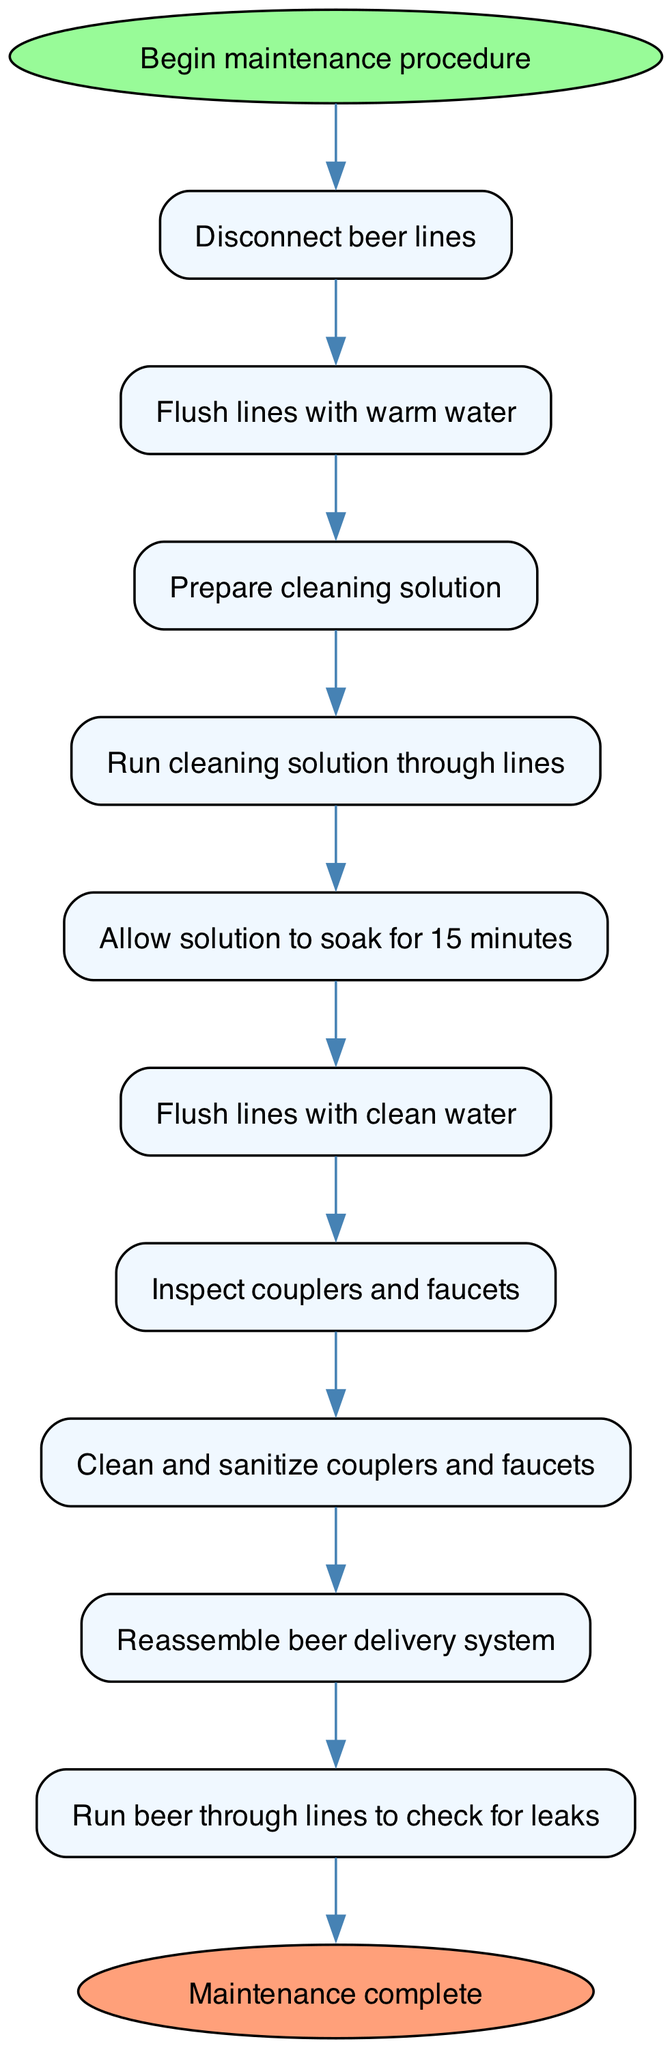What is the first step in the maintenance procedure? The first step is represented by the first node after the start point. It states "Disconnect beer lines," which indicates what action should begin the maintenance procedure.
Answer: Disconnect beer lines How many total steps are there in the diagram? The diagram includes ten steps plus a start and end point, making a total of twelve nodes when counting all the points. Therefore, the count of individual steps is ten.
Answer: Ten What step comes after flushing lines with clean water? To find this, we look at the flow from the step "Flush lines with clean water," which directly leads to the next step, "Inspect couplers and faucets."
Answer: Inspect couplers and faucets What is the last action taken in the maintenance process? The last action is indicated by the last step in the sequence before reaching the end point. It states "Run beer through lines to check for leaks," showing what concludes the maintenance.
Answer: Run beer through lines to check for leaks How long should the cleaning solution soak? The step specifies the soaking duration as "15 minutes," which is stated directly in the step detailing the duration of the soak for effective cleaning.
Answer: 15 minutes Which step involves cleaning and sanitizing? Referring to the step before the final assembly, the diagram specifies "Clean and sanitize couplers and faucets," identifying the maintenance action performed regarding cleaning these components.
Answer: Clean and sanitize couplers and faucets What comes immediately after preparing the cleaning solution? By analyzing the flow from the step "Prepare cleaning solution," it is clear that the next step is "Run cleaning solution through lines," indicating the order of procedural actions.
Answer: Run cleaning solution through lines What equipment is inspected before reassembling the system? The diagram details that prior to reassembly, the process requires an "Inspect couplers and faucets" step, indicating what equipment needs inspection before the final steps.
Answer: Inspect couplers and faucets What is the start point of the maintenance procedure? The start point is specified at the very beginning of the diagram as "Begin maintenance procedure," clearly stating the initiation of the process.
Answer: Begin maintenance procedure 